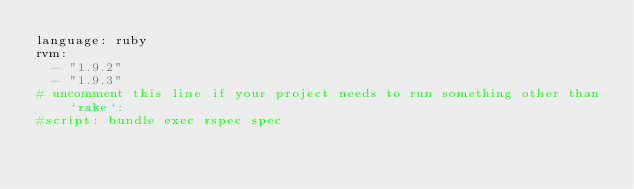Convert code to text. <code><loc_0><loc_0><loc_500><loc_500><_YAML_>language: ruby
rvm:
  - "1.9.2"
  - "1.9.3"
# uncomment this line if your project needs to run something other than `rake`:
#script: bundle exec rspec spec</code> 